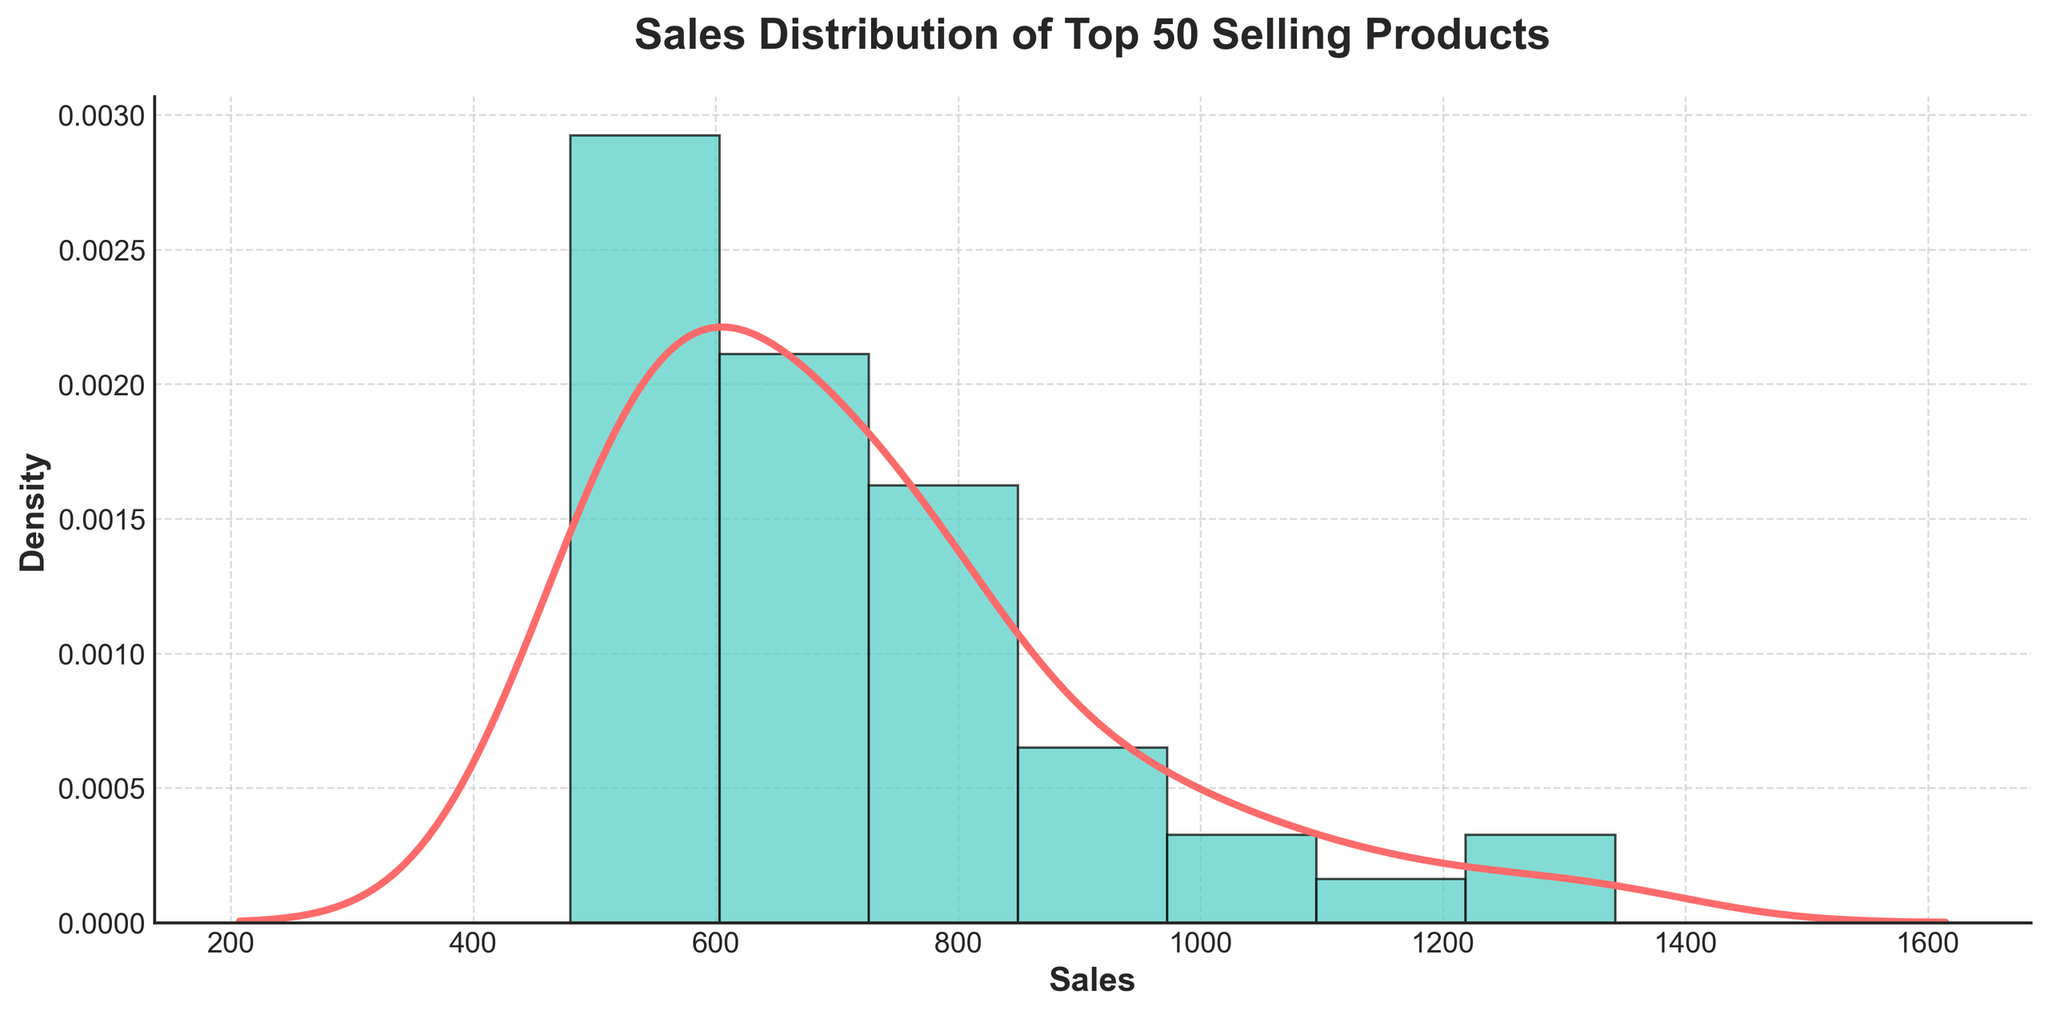What is the title of the plot? The title of the plot is a key aspect as it provides an overview of what the visualization represents. In the figure, the text at the top states the title.
Answer: Sales Distribution of Top 50 Selling Products What is the x-axis label of the plot? The x-axis label is the text that describes what the x-axis represents. It can be found below the horizontal axis in the figure.
Answer: Sales What does the y-axis represent in the plot? The y-axis represents the density of the sales distribution. This can be deduced from the y-axis label.
Answer: Density How does the plot visually differentiate between the histogram and the KDE (Kernel Density Estimate) line? The plot uses different colors and styles to distinguish between the histogram bars and the KDE line. The histogram bars have a specific color and edge, while the KDE line has a different color and is smoother.
Answer: Histogram bars are teal with black edges, KDE line is red and smooth Do the sales figures have a right-skewed distribution or a left-skewed distribution? Right-skewed distributions have a long tail on the right side, indicating that a higher number of observations have lower values. The plot shows where most of the sales data is concentrated and how the tail extends.
Answer: Right-skewed distribution What range of sales values has the highest density? To determine the range with the highest density, observe where the KDE peak is situated along the x-axis. This tells us where most of the product sales are clustered.
Answer: Between 500 and 800 Approximately how many products have sales figures above 1000? Identify the segment of the x-axis above 1000 and observe the histogram to estimate the number of products in this range. Although the exact count is not provided, a rough estimate can be made by counting the bars.
Answer: Around 4 products What can you infer about the sales performance of the products based on the distribution? Analyze the shape and spread of the distribution to draw conclusions about product sales performance. Consider where the majority of the data points lie and the skewness of the distribution.
Answer: Most products have sales between 500 and 1000, suggesting moderate sales for the majority. A few products have sales above 1000, indicating high-performance outliers Is the distribution unimodal or multimodal? Determine if the distribution has one peak (unimodal) or multiple peaks (multimodal) by analyzing the KDE line on the plot. The number of peaks indicates the modes.
Answer: Unimodal What sales figure marks the approximate median of the data? To find the median, locate the midpoint of the data distribution along the sales axis. In a right-skewed distribution, the median will be somewhere towards the left of the center.
Answer: Roughly around 750 